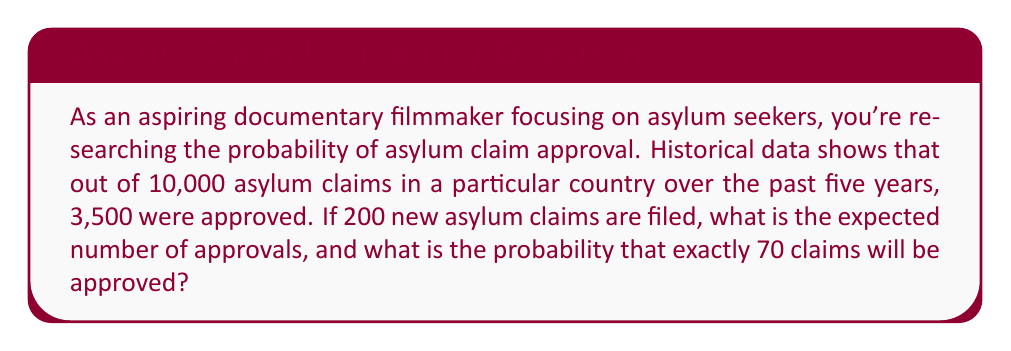Give your solution to this math problem. To solve this problem, we'll use concepts from probability theory:

1. Calculate the probability of a single claim being approved:
   $p = \frac{\text{Number of approved claims}}{\text{Total number of claims}} = \frac{3500}{10000} = 0.35$

2. Expected number of approvals for 200 new claims:
   The expected value is calculated by multiplying the number of trials by the probability of success.
   $E(X) = np = 200 \times 0.35 = 70$

3. Probability of exactly 70 approvals out of 200 claims:
   This follows a binomial distribution. We'll use the binomial probability formula:

   $P(X = k) = \binom{n}{k} p^k (1-p)^{n-k}$

   Where:
   $n = 200$ (number of trials)
   $k = 70$ (number of successes)
   $p = 0.35$ (probability of success)

   $P(X = 70) = \binom{200}{70} (0.35)^{70} (0.65)^{130}$

   $= \frac{200!}{70!(200-70)!} (0.35)^{70} (0.65)^{130}$

   $\approx 0.0608$ or about 6.08%

The calculation of the binomial coefficient and the final probability can be done using a calculator or computer due to the large numbers involved.
Answer: The expected number of approvals is 70, and the probability of exactly 70 approvals is approximately 0.0608 or 6.08%. 